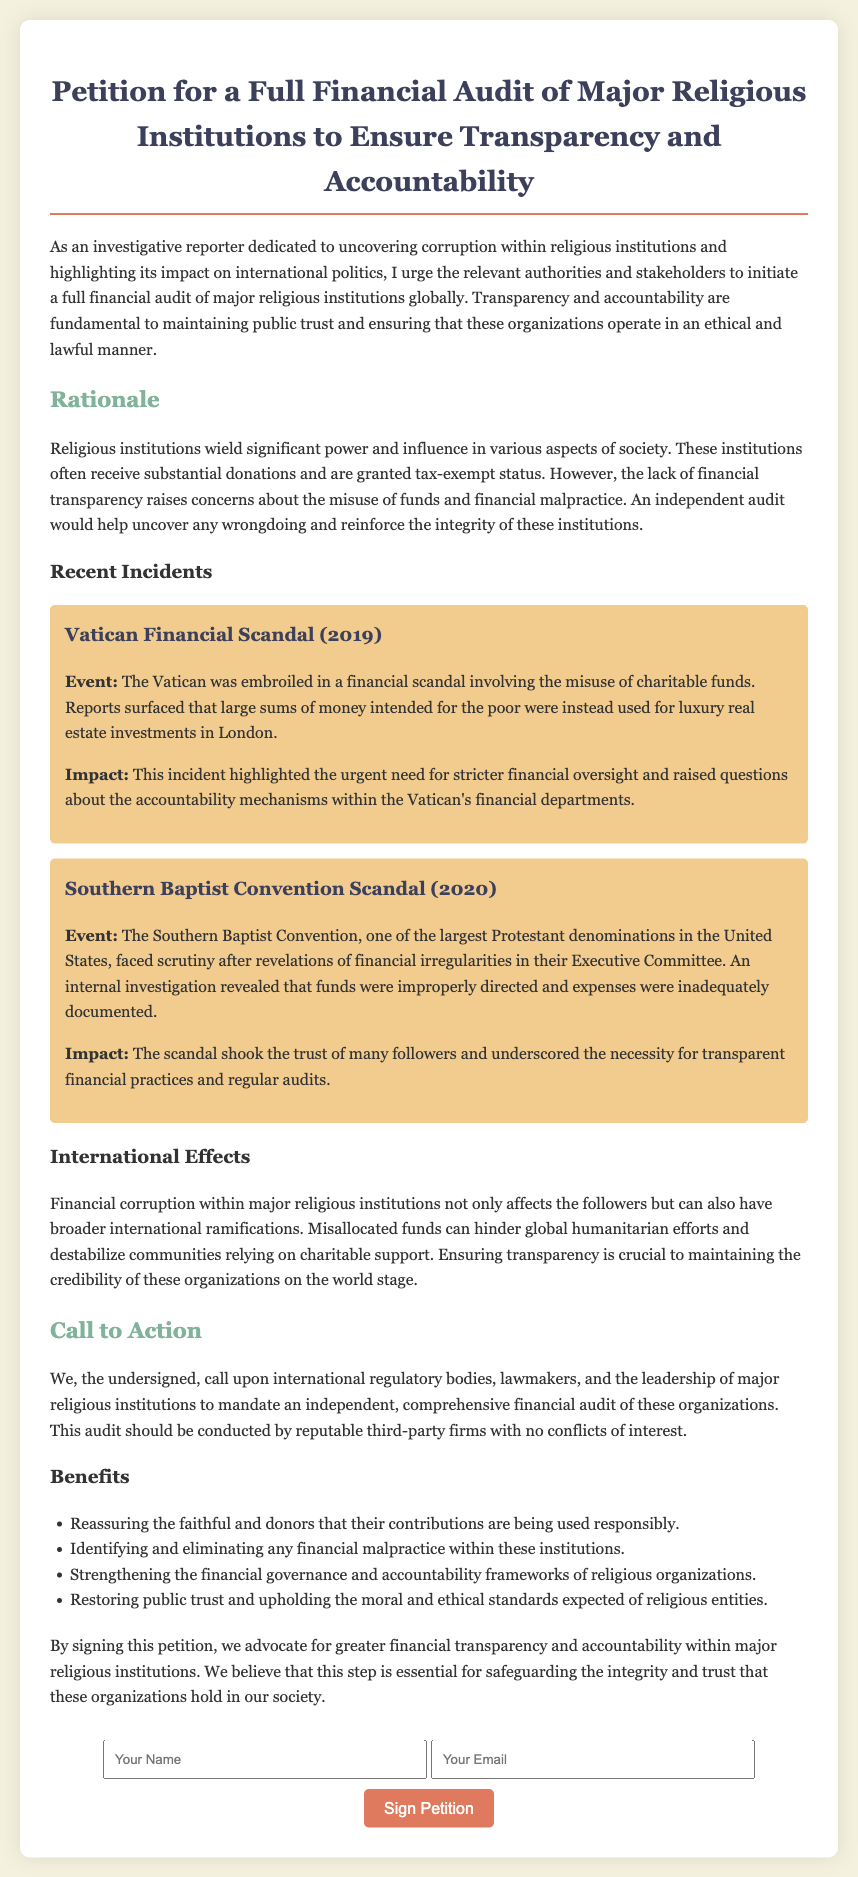What is the title of the petition? The title is explicitly stated at the top of the document, which is about the financial audit of religious institutions.
Answer: Petition for a Full Financial Audit of Major Religious Institutions to Ensure Transparency and Accountability What year was the Vatican Financial Scandal? The incident mentions the year it occurred in its title, indicating a specific event related to financial misconduct.
Answer: 2019 What is one of the major impacts of the Vatican scandal? The document denotes the consequences of the scandal as highlighted under its impact section.
Answer: Need for stricter financial oversight What is the main call to action in the petition? The call to action is a fundamental request outlined in the petition which emphasizes the main objective.
Answer: Mandate an independent, comprehensive financial audit How many recent incidents are mentioned in the rationale section? The rationale section lists two major incidents as examples of financial malpractice.
Answer: Two What does financial corruption in religious institutions hinder according to the document? The text specifies a broader effect of financial corruption in terms of humanitarian efforts when discussing international consequences.
Answer: Global humanitarian efforts What should the audit be conducted by? The petition specifies the type of organization that should carry out the financial audit as a fundamental requirement.
Answer: Reputable third-party firms What color is used for the heading that discusses recent incidents? The document uses specific color codes for different sections, which can be inferred from the style definitions provided.
Answer: Dark blue What is emphasized as a benefit of conducting the audit? The document outlines several advantages of an audit in the benefits section, indicating what is gained through transparency.
Answer: Restoring public trust 